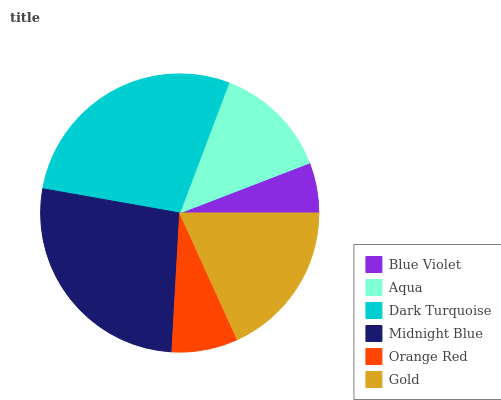Is Blue Violet the minimum?
Answer yes or no. Yes. Is Dark Turquoise the maximum?
Answer yes or no. Yes. Is Aqua the minimum?
Answer yes or no. No. Is Aqua the maximum?
Answer yes or no. No. Is Aqua greater than Blue Violet?
Answer yes or no. Yes. Is Blue Violet less than Aqua?
Answer yes or no. Yes. Is Blue Violet greater than Aqua?
Answer yes or no. No. Is Aqua less than Blue Violet?
Answer yes or no. No. Is Gold the high median?
Answer yes or no. Yes. Is Aqua the low median?
Answer yes or no. Yes. Is Orange Red the high median?
Answer yes or no. No. Is Gold the low median?
Answer yes or no. No. 